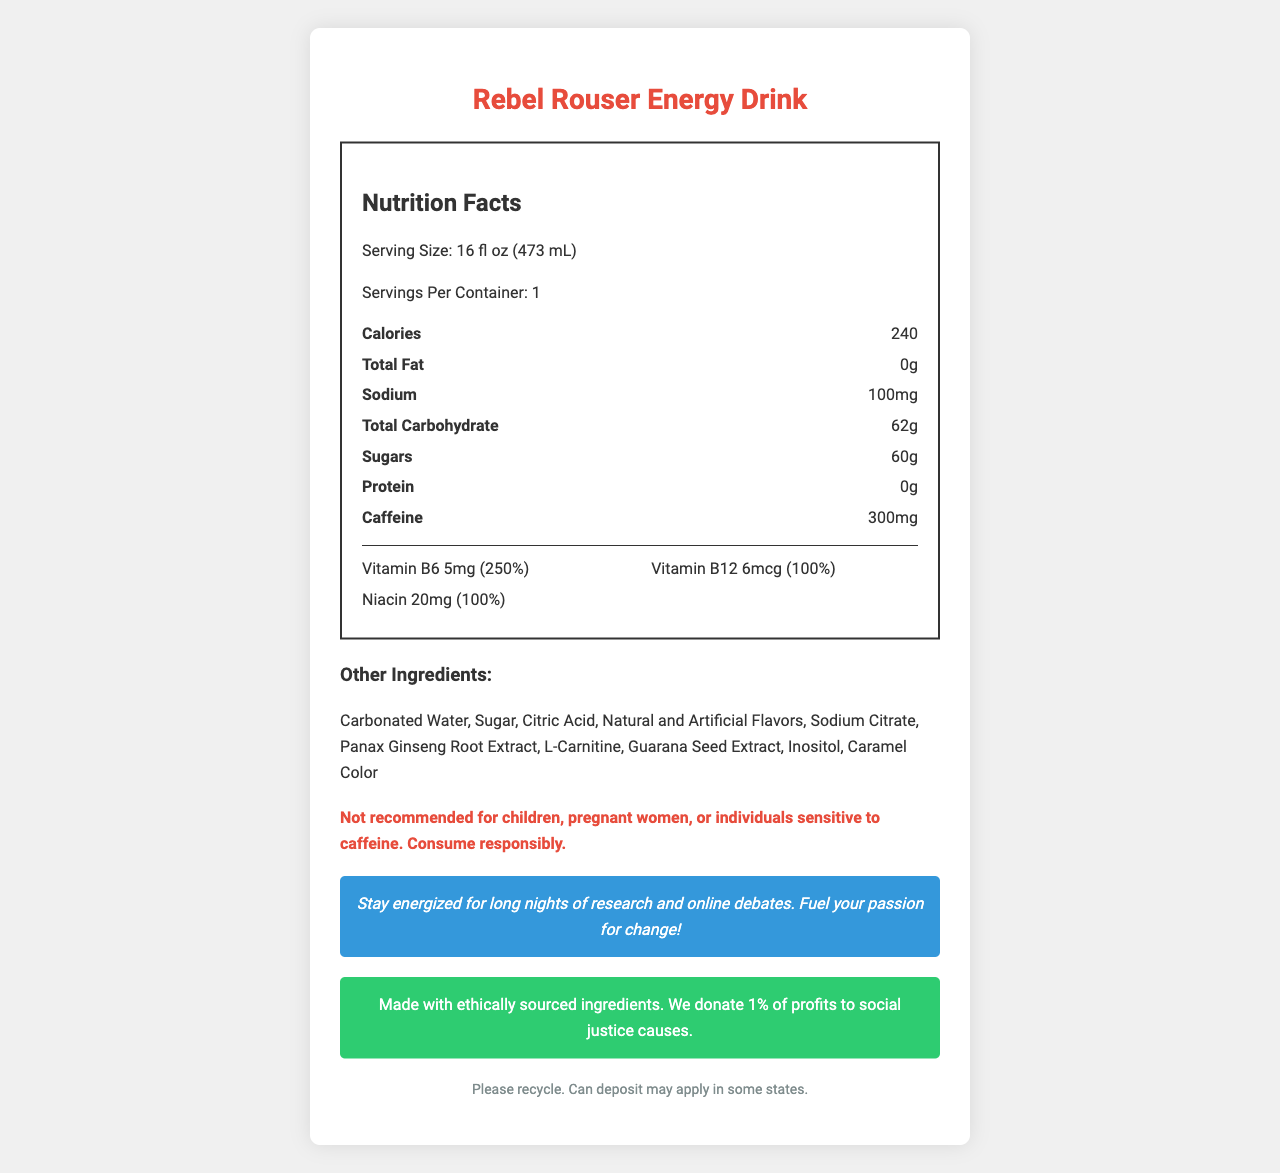what is the serving size? The serving size is mentioned right under the "Nutrition Facts" title.
Answer: 16 fl oz (473 mL) how much caffeine does the Rebel Rouser Energy Drink contain? The caffeine content is listed as one of the key nutrition facts under "Nutrition Facts".
Answer: 300mg how many vitamins and minerals are listed in the nutrition label? The document lists Vitamin B6, Vitamin B12, and Niacin.
Answer: Three what is the sodium content? The sodium content is presented in the nutrition facts section.
Answer: 100mg how much sugar is in one serving? The sugar content is listed under "Total Carbohydrate" in the nutrition facts.
Answer: 60g what is the daily value percentage for Vitamin B6? The daily value for Vitamin B6 is 250%, as stated under the vitamins section.
Answer: 250% how many servings are there per container? The servings per container is mentioned as 1 right below the serving size.
Answer: 1 what are the ethical practices mentioned in the document? The ethical sourcing statement highlights these practices.
Answer: Made with ethically sourced ingredients. We donate 1% of profits to social justice causes. is Rebel Rouser Energy Drink recommended for children? The warning section explicitly states it is not recommended for children, pregnant women, or individuals sensitive to caffeine.
Answer: No what ingredients in the energy drink could contribute to an increase in energy? These ingredients are known for their energy-boosting properties.
Answer: Caffeine, Guarana Seed Extract, Panax Ginseng Root Extract how many calories are in one can? A. 100 B. 150 C. 240 D. 300 The document lists 240 calories under the nutrition facts section.
Answer: C how much protein is present in the drink? The protein content is listed under "Nutrition Facts" as 0g.
Answer: 0g what is the social message related to the product? This message is highlighted in the activist message section.
Answer: Stay energized for long nights of research and online debates. Fuel your passion for change! what is the color of the background for the ethical sourcing statement? The ethical sourcing statement has a green background as per the styling section.
Answer: Green can we determine the price of the Rebel Rouser Energy Drink from the document? The document does not provide any information about the price of the energy drink.
Answer: Cannot be determined 